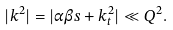Convert formula to latex. <formula><loc_0><loc_0><loc_500><loc_500>| k ^ { 2 } | = | \alpha \beta s + k _ { t } ^ { 2 } | \ll Q ^ { 2 } .</formula> 